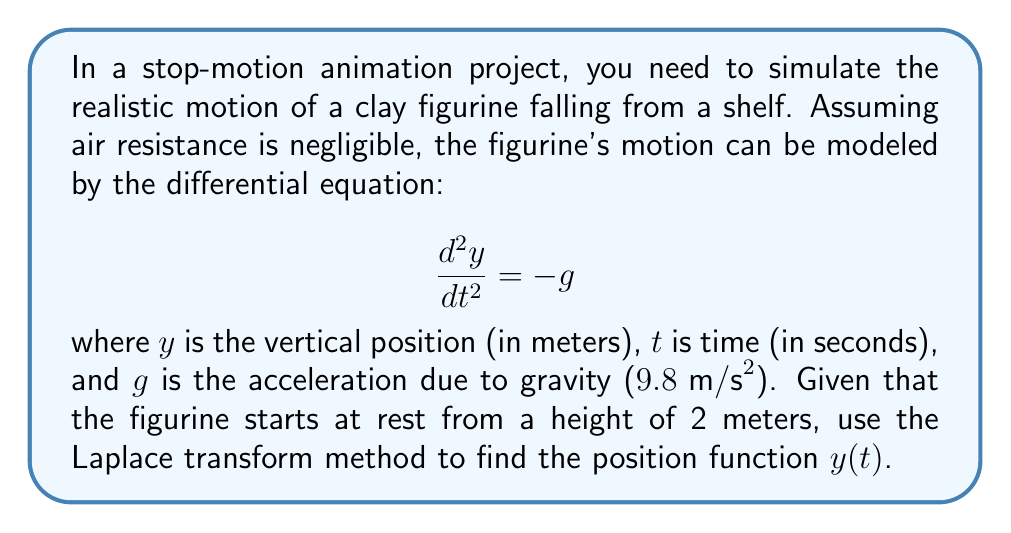Solve this math problem. Let's solve this step-by-step using the Laplace transform method:

1) First, we take the Laplace transform of both sides of the equation:

   $\mathcal{L}\left\{\frac{d^2y}{dt^2}\right\} = \mathcal{L}\{-g\}$

2) Using the Laplace transform properties:

   $s^2Y(s) - sy(0) - y'(0) = -\frac{g}{s}$

   Where $Y(s)$ is the Laplace transform of $y(t)$, $y(0)$ is the initial position, and $y'(0)$ is the initial velocity.

3) We're given that $y(0) = 2$ (starts at 2 meters) and $y'(0) = 0$ (starts at rest). Substituting:

   $s^2Y(s) - 2s = -\frac{g}{s}$

4) Solving for $Y(s)$:

   $Y(s) = \frac{2s}{s^2} + \frac{g}{s^3} = \frac{2}{s} + \frac{g}{s^3}$

5) Now we need to find the inverse Laplace transform. We can use the standard Laplace transform pairs:

   $\mathcal{L}^{-1}\left\{\frac{1}{s}\right\} = 1$
   $\mathcal{L}^{-1}\left\{\frac{1}{s^3}\right\} = \frac{t^2}{2}$

6) Therefore:

   $y(t) = 2 + \frac{g}{2}t^2 = 2 + \frac{9.8}{2}t^2 = 2 + 4.9t^2$

This gives us the position of the figurine as a function of time.
Answer: $y(t) = 2 + 4.9t^2$ meters 